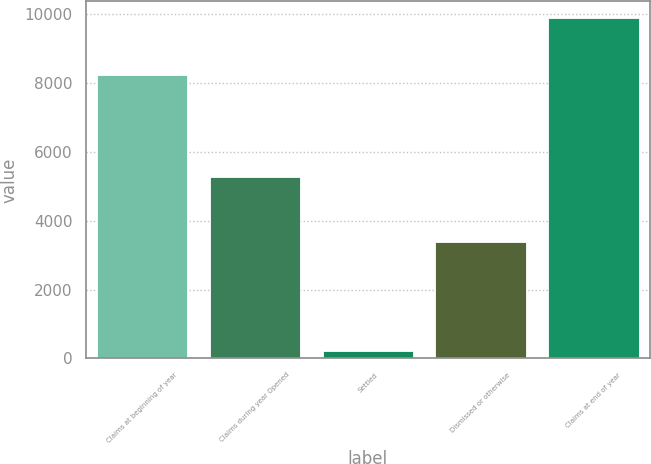Convert chart to OTSL. <chart><loc_0><loc_0><loc_500><loc_500><bar_chart><fcel>Claims at beginning of year<fcel>Claims during year Opened<fcel>Settled<fcel>Dismissed or otherwise<fcel>Claims at end of year<nl><fcel>8216<fcel>5253<fcel>219<fcel>3377<fcel>9873<nl></chart> 